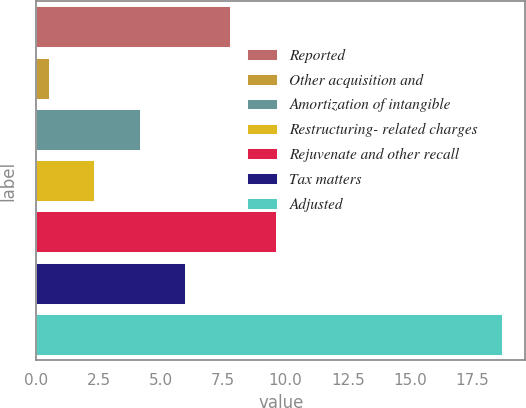Convert chart to OTSL. <chart><loc_0><loc_0><loc_500><loc_500><bar_chart><fcel>Reported<fcel>Other acquisition and<fcel>Amortization of intangible<fcel>Restructuring- related charges<fcel>Rejuvenate and other recall<fcel>Tax matters<fcel>Adjusted<nl><fcel>7.78<fcel>0.5<fcel>4.14<fcel>2.32<fcel>9.6<fcel>5.96<fcel>18.7<nl></chart> 